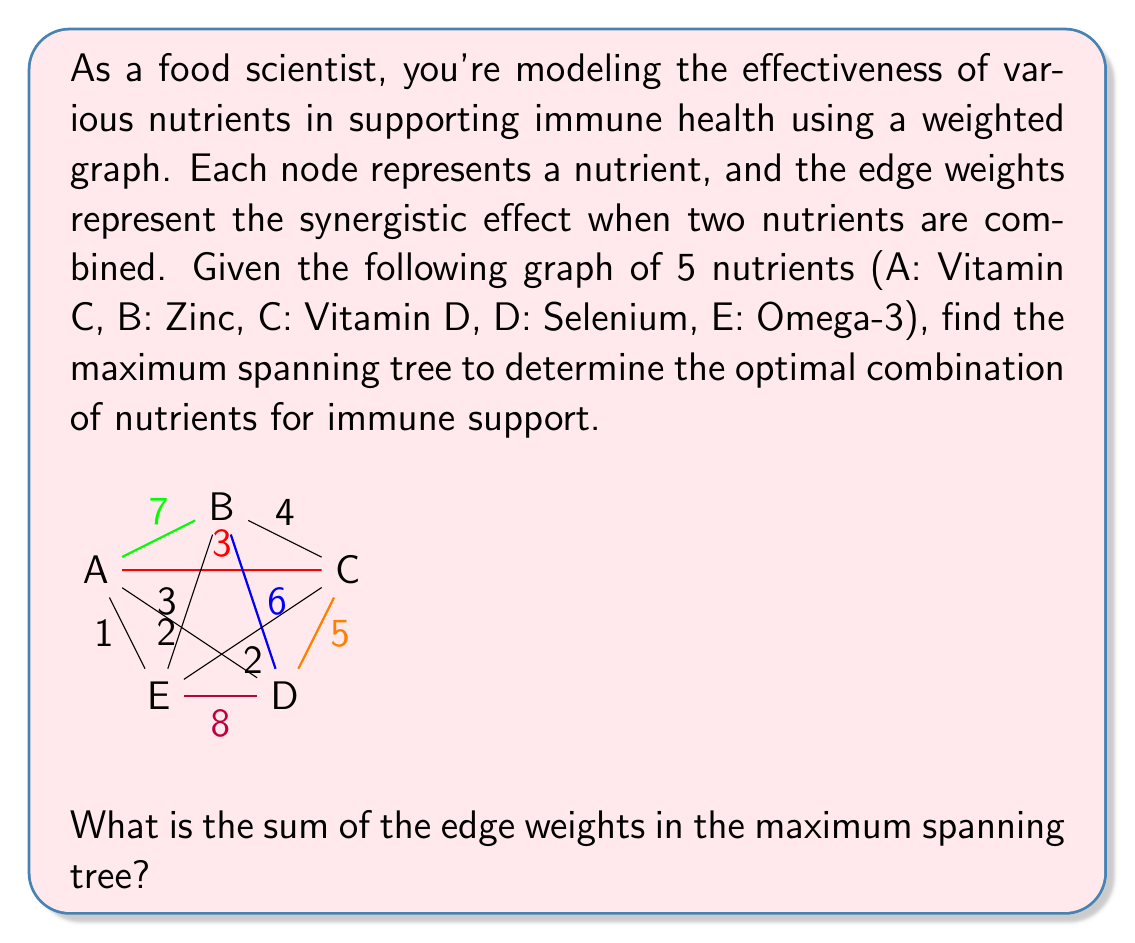Show me your answer to this math problem. To find the maximum spanning tree, we can use Kruskal's algorithm, but instead of selecting the smallest edge weights, we'll select the largest.

Steps:
1. Sort the edges by weight in descending order:
   DE (8), AB (7), BD (6), CD (5), BC (4), AC (3), BE (3), AD (2), CE (2), AE (1)

2. Add edges to the tree, skipping those that would create a cycle:
   - Add DE (8)
   - Add AB (7)
   - Add BD (6)
   - Skip CD (5) as it would create a cycle
   - Skip BC (4) as it would create a cycle
   - Add AC (3)

3. We now have a spanning tree with 4 edges (the number of nodes minus 1).

The maximum spanning tree consists of the edges:
DE (8), AB (7), BD (6), and AC (3)

To find the sum of the edge weights, we add these values:

$$8 + 7 + 6 + 3 = 24$$

This maximum spanning tree represents the optimal combination of nutrients for immune support, maximizing the synergistic effects between the nutrients.
Answer: 24 